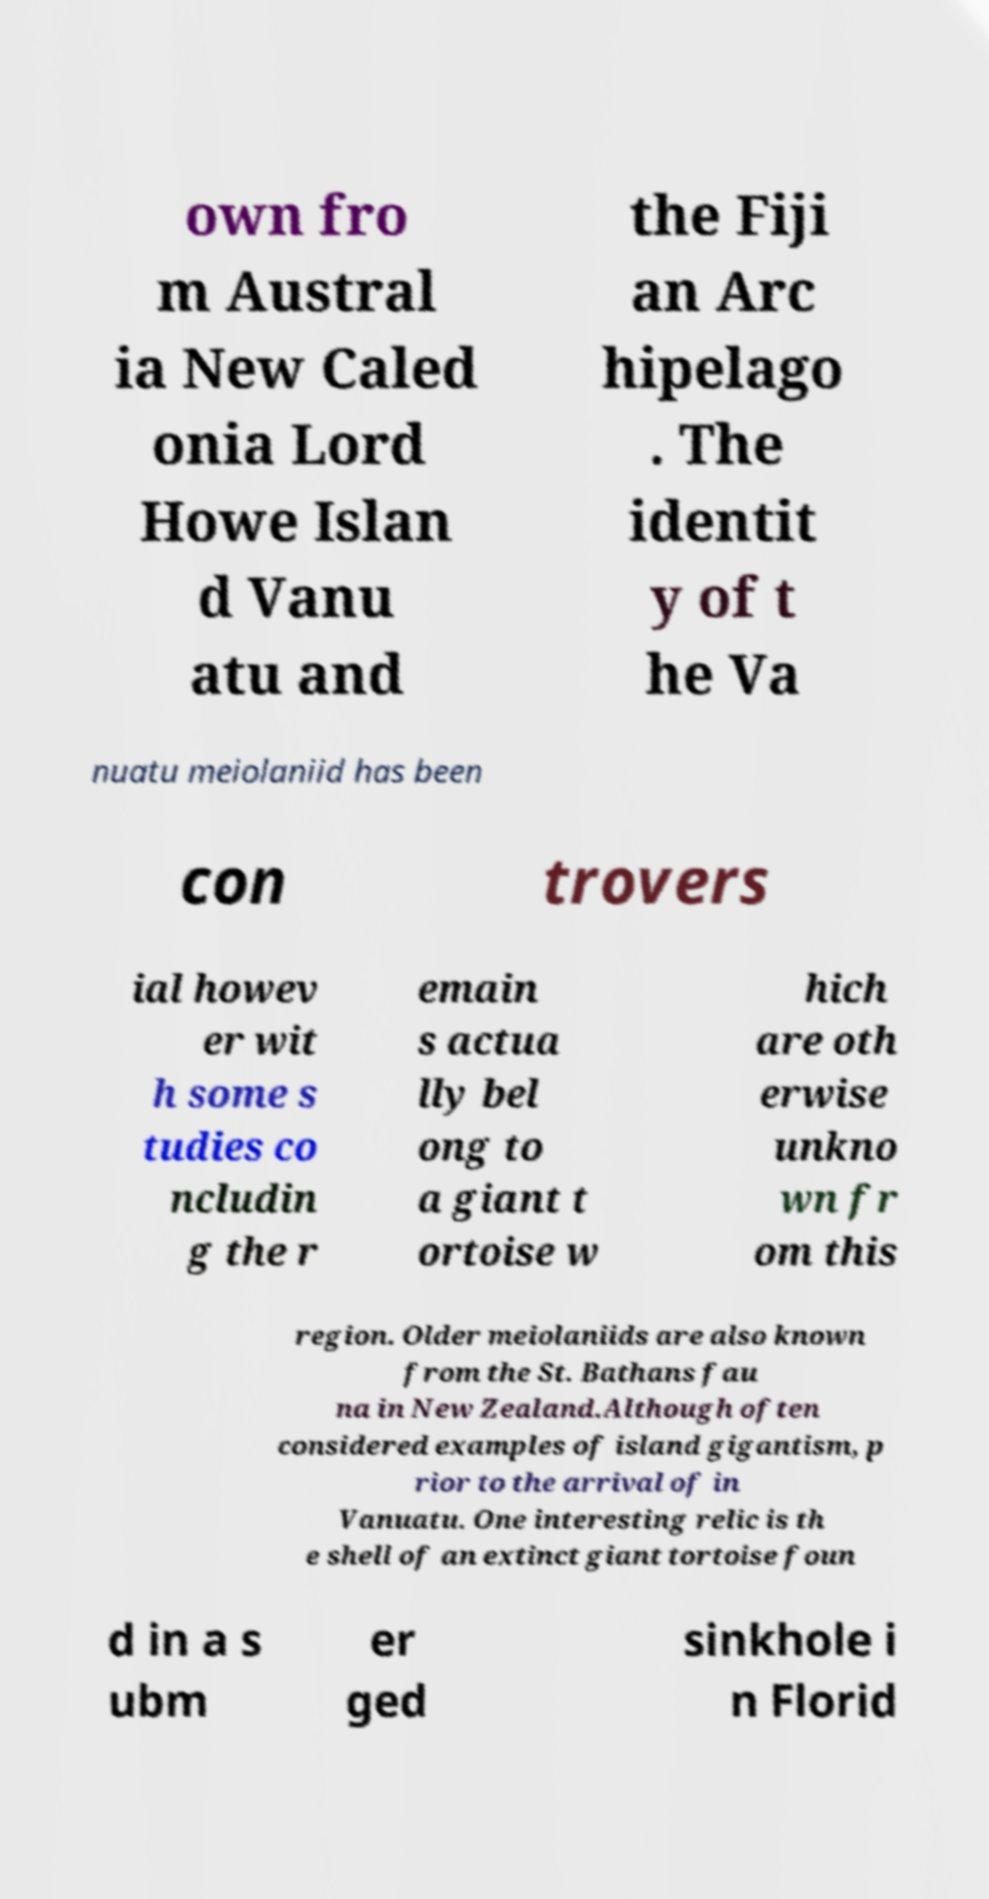Please read and relay the text visible in this image. What does it say? own fro m Austral ia New Caled onia Lord Howe Islan d Vanu atu and the Fiji an Arc hipelago . The identit y of t he Va nuatu meiolaniid has been con trovers ial howev er wit h some s tudies co ncludin g the r emain s actua lly bel ong to a giant t ortoise w hich are oth erwise unkno wn fr om this region. Older meiolaniids are also known from the St. Bathans fau na in New Zealand.Although often considered examples of island gigantism, p rior to the arrival of in Vanuatu. One interesting relic is th e shell of an extinct giant tortoise foun d in a s ubm er ged sinkhole i n Florid 